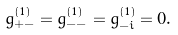<formula> <loc_0><loc_0><loc_500><loc_500>g _ { + - } ^ { ( 1 ) } = g _ { - - } ^ { ( 1 ) } = g _ { - i } ^ { ( 1 ) } = 0 .</formula> 